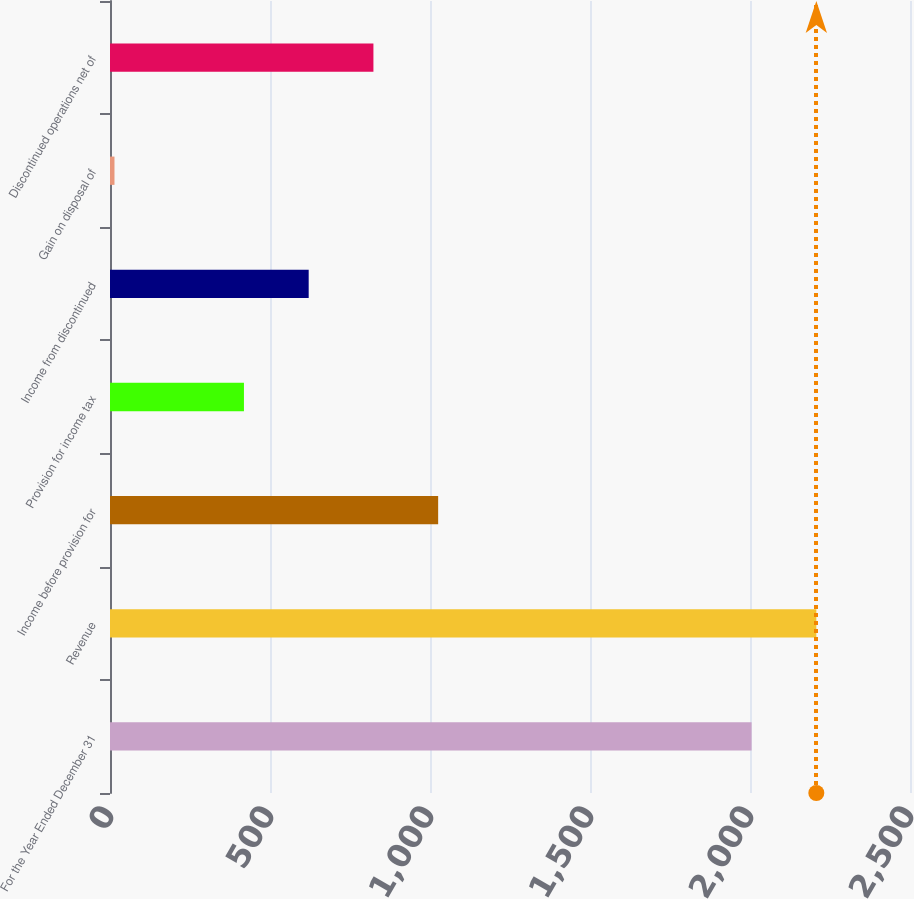Convert chart. <chart><loc_0><loc_0><loc_500><loc_500><bar_chart><fcel>For the Year Ended December 31<fcel>Revenue<fcel>Income before provision for<fcel>Provision for income tax<fcel>Income from discontinued<fcel>Gain on disposal of<fcel>Discontinued operations net of<nl><fcel>2005<fcel>2207.3<fcel>1025.5<fcel>418.6<fcel>620.9<fcel>14<fcel>823.2<nl></chart> 